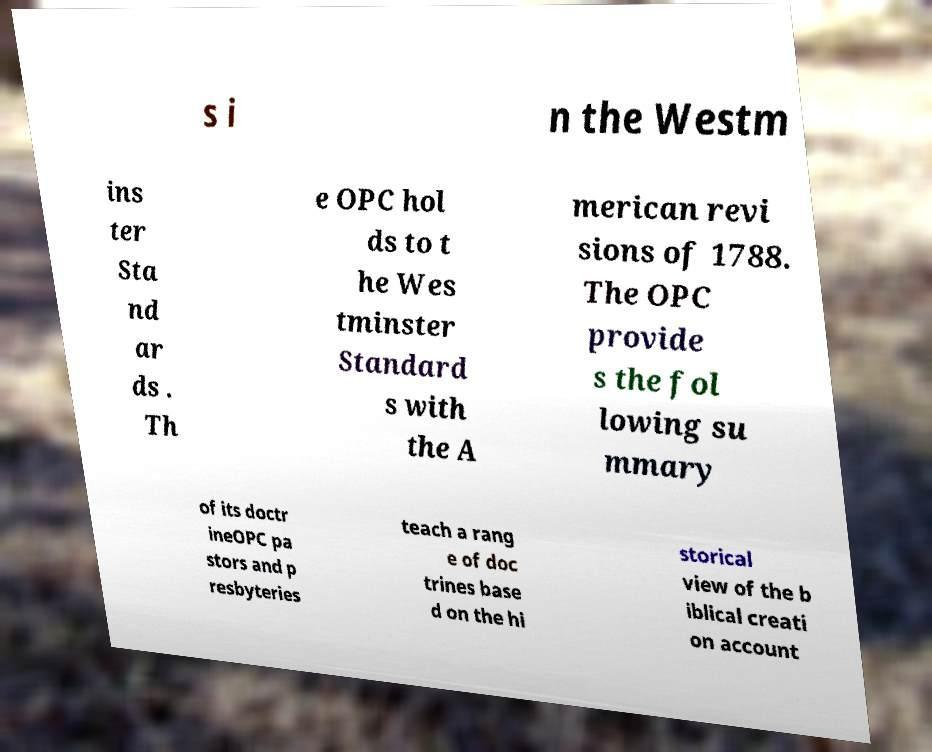There's text embedded in this image that I need extracted. Can you transcribe it verbatim? s i n the Westm ins ter Sta nd ar ds . Th e OPC hol ds to t he Wes tminster Standard s with the A merican revi sions of 1788. The OPC provide s the fol lowing su mmary of its doctr ineOPC pa stors and p resbyteries teach a rang e of doc trines base d on the hi storical view of the b iblical creati on account 